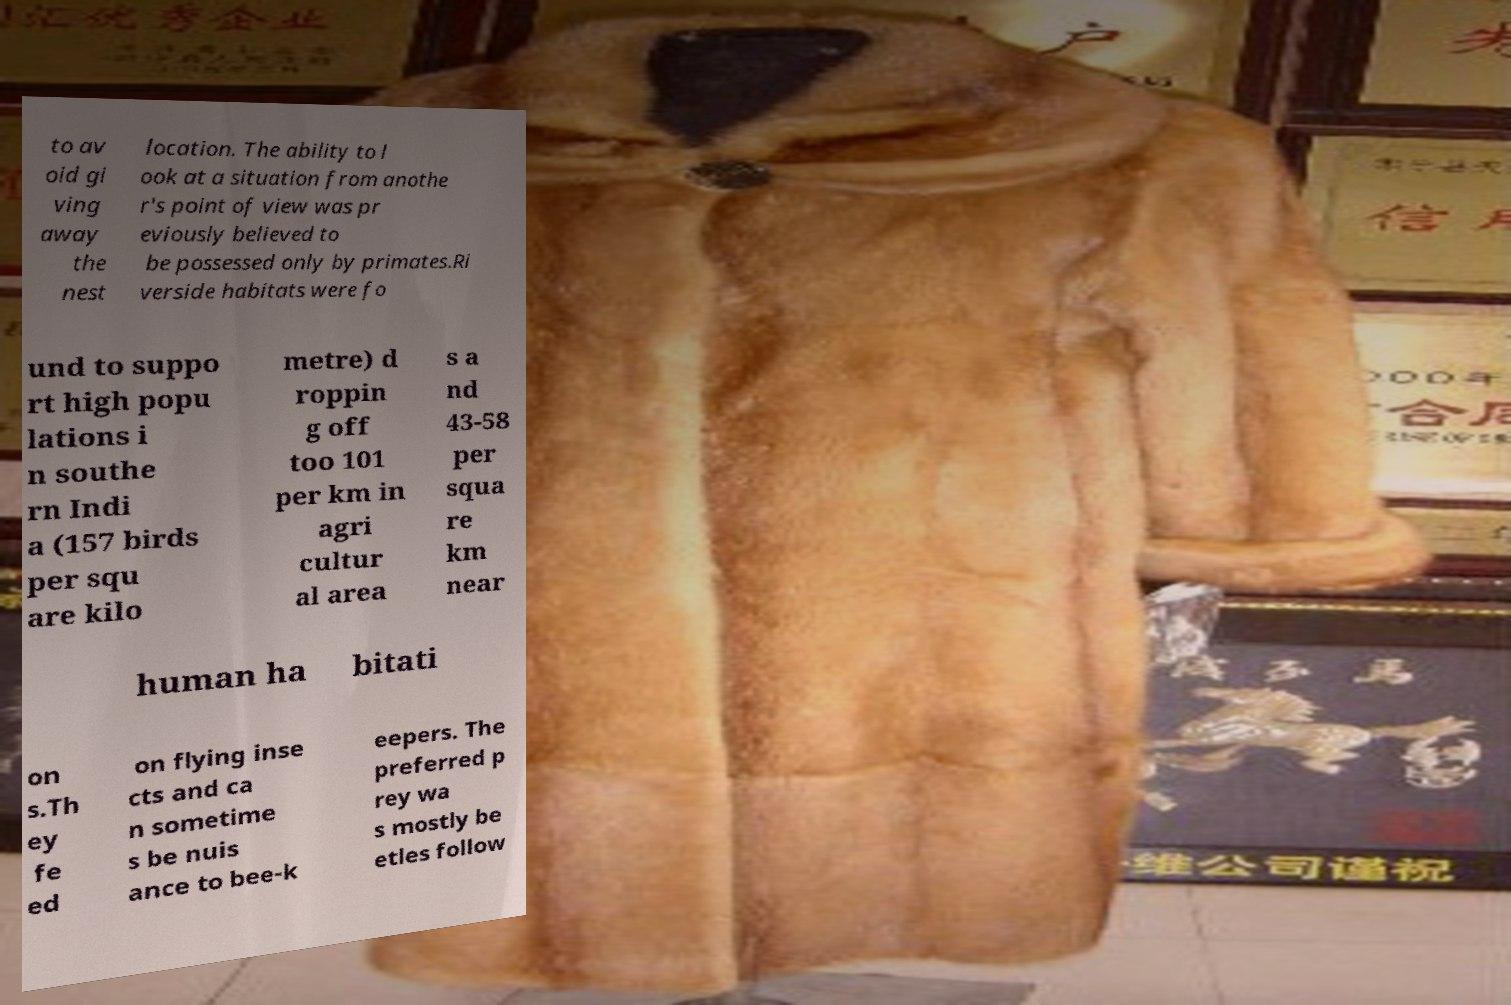What messages or text are displayed in this image? I need them in a readable, typed format. to av oid gi ving away the nest location. The ability to l ook at a situation from anothe r's point of view was pr eviously believed to be possessed only by primates.Ri verside habitats were fo und to suppo rt high popu lations i n southe rn Indi a (157 birds per squ are kilo metre) d roppin g off too 101 per km in agri cultur al area s a nd 43-58 per squa re km near human ha bitati on s.Th ey fe ed on flying inse cts and ca n sometime s be nuis ance to bee-k eepers. The preferred p rey wa s mostly be etles follow 